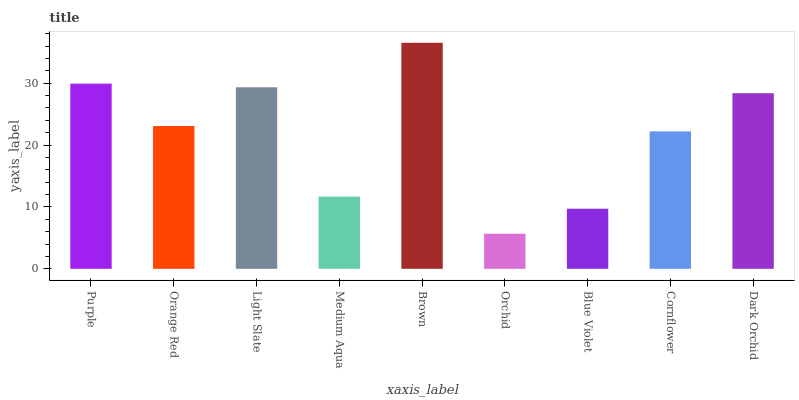Is Orchid the minimum?
Answer yes or no. Yes. Is Brown the maximum?
Answer yes or no. Yes. Is Orange Red the minimum?
Answer yes or no. No. Is Orange Red the maximum?
Answer yes or no. No. Is Purple greater than Orange Red?
Answer yes or no. Yes. Is Orange Red less than Purple?
Answer yes or no. Yes. Is Orange Red greater than Purple?
Answer yes or no. No. Is Purple less than Orange Red?
Answer yes or no. No. Is Orange Red the high median?
Answer yes or no. Yes. Is Orange Red the low median?
Answer yes or no. Yes. Is Blue Violet the high median?
Answer yes or no. No. Is Light Slate the low median?
Answer yes or no. No. 